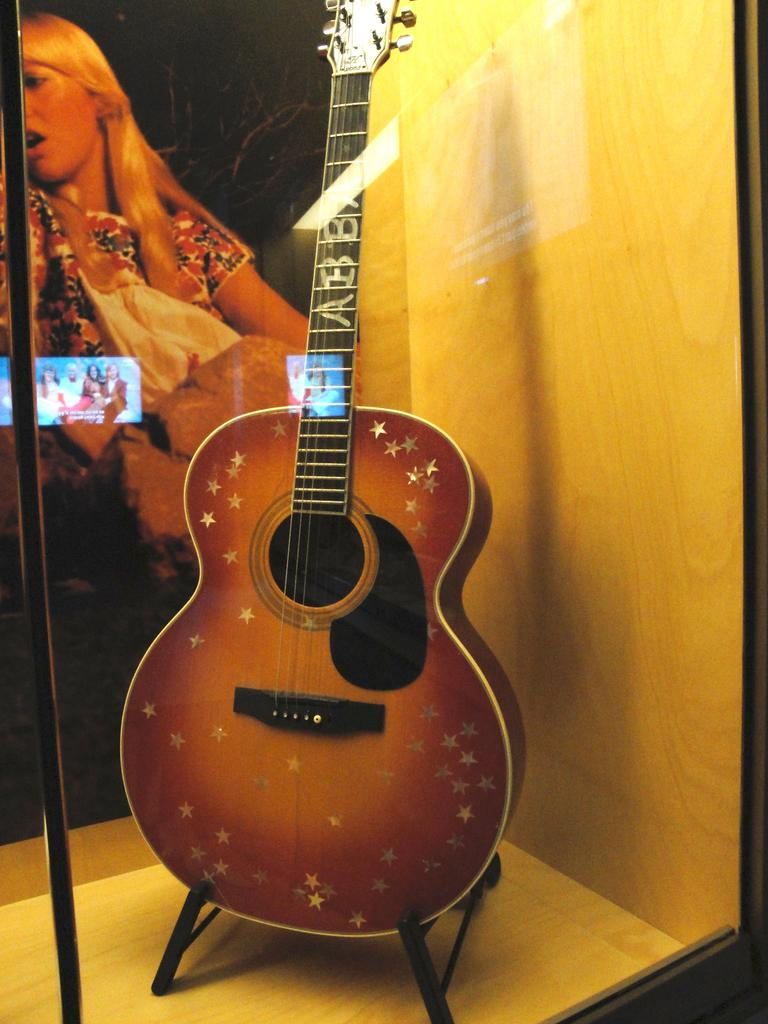What musical instrument is present in the image? There is a guitar in the image. Where is the guitar located? The guitar is placed in a gallery. How many trucks can be seen crossing the stream in the image? There are no trucks or streams present in the image; it features a guitar in a gallery. 